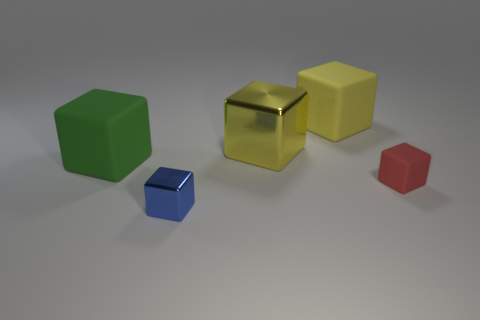Subtract all tiny red blocks. How many blocks are left? 4 Subtract all blue blocks. Subtract all red spheres. How many blocks are left? 4 Add 3 yellow objects. How many objects exist? 8 Subtract 0 purple blocks. How many objects are left? 5 Subtract all small red rubber cylinders. Subtract all large yellow matte blocks. How many objects are left? 4 Add 3 green objects. How many green objects are left? 4 Add 3 small brown cylinders. How many small brown cylinders exist? 3 